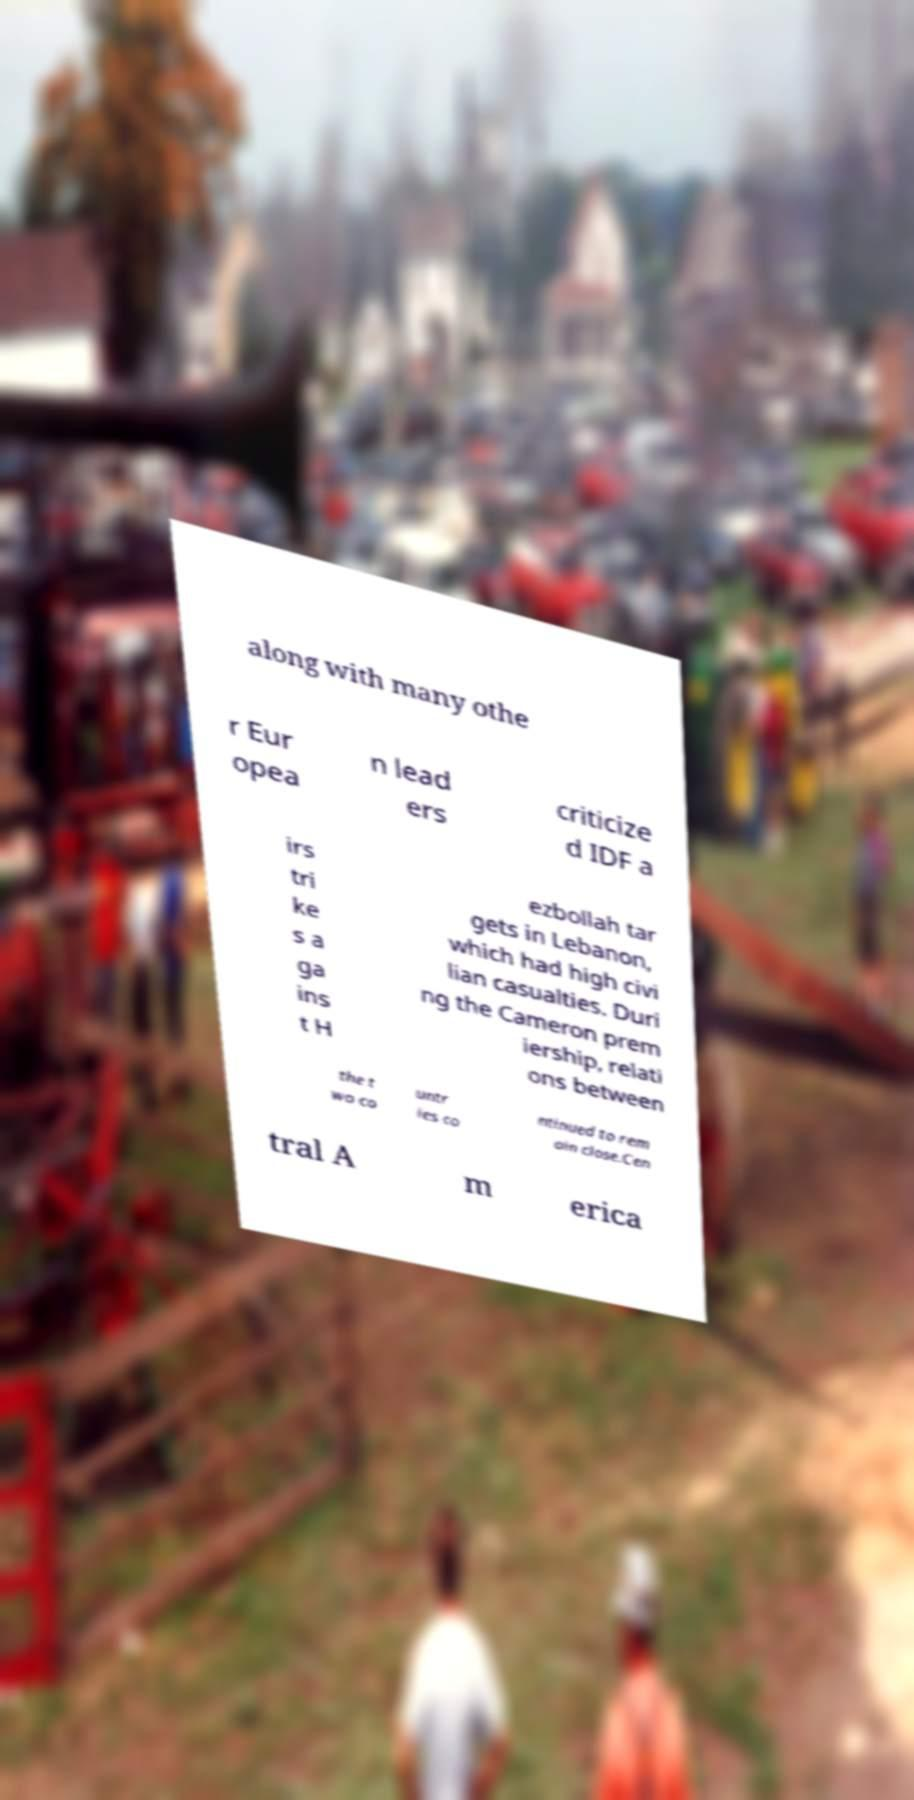There's text embedded in this image that I need extracted. Can you transcribe it verbatim? along with many othe r Eur opea n lead ers criticize d IDF a irs tri ke s a ga ins t H ezbollah tar gets in Lebanon, which had high civi lian casualties. Duri ng the Cameron prem iership, relati ons between the t wo co untr ies co ntinued to rem ain close.Cen tral A m erica 